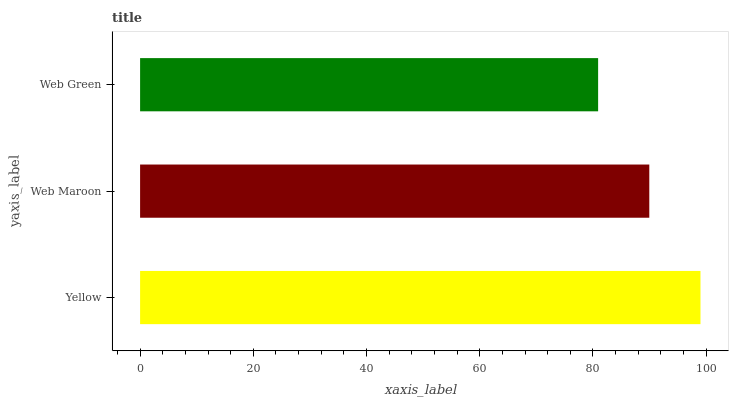Is Web Green the minimum?
Answer yes or no. Yes. Is Yellow the maximum?
Answer yes or no. Yes. Is Web Maroon the minimum?
Answer yes or no. No. Is Web Maroon the maximum?
Answer yes or no. No. Is Yellow greater than Web Maroon?
Answer yes or no. Yes. Is Web Maroon less than Yellow?
Answer yes or no. Yes. Is Web Maroon greater than Yellow?
Answer yes or no. No. Is Yellow less than Web Maroon?
Answer yes or no. No. Is Web Maroon the high median?
Answer yes or no. Yes. Is Web Maroon the low median?
Answer yes or no. Yes. Is Yellow the high median?
Answer yes or no. No. Is Web Green the low median?
Answer yes or no. No. 